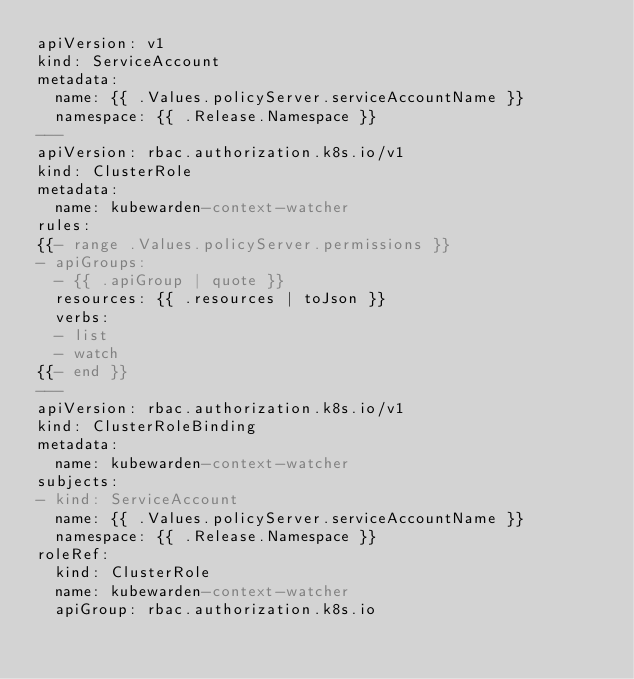Convert code to text. <code><loc_0><loc_0><loc_500><loc_500><_YAML_>apiVersion: v1
kind: ServiceAccount
metadata:
  name: {{ .Values.policyServer.serviceAccountName }}
  namespace: {{ .Release.Namespace }}
---
apiVersion: rbac.authorization.k8s.io/v1
kind: ClusterRole
metadata:
  name: kubewarden-context-watcher
rules:
{{- range .Values.policyServer.permissions }}
- apiGroups:
  - {{ .apiGroup | quote }}
  resources: {{ .resources | toJson }}
  verbs:
  - list
  - watch
{{- end }}
---
apiVersion: rbac.authorization.k8s.io/v1
kind: ClusterRoleBinding
metadata:
  name: kubewarden-context-watcher
subjects:
- kind: ServiceAccount
  name: {{ .Values.policyServer.serviceAccountName }}
  namespace: {{ .Release.Namespace }}
roleRef:
  kind: ClusterRole
  name: kubewarden-context-watcher
  apiGroup: rbac.authorization.k8s.io
</code> 